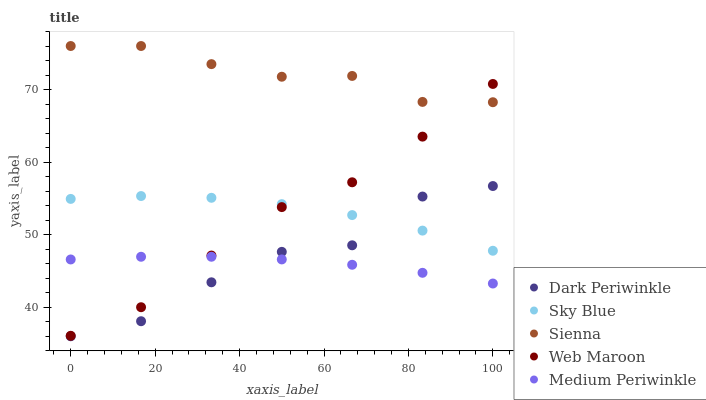Does Medium Periwinkle have the minimum area under the curve?
Answer yes or no. Yes. Does Sienna have the maximum area under the curve?
Answer yes or no. Yes. Does Sky Blue have the minimum area under the curve?
Answer yes or no. No. Does Sky Blue have the maximum area under the curve?
Answer yes or no. No. Is Medium Periwinkle the smoothest?
Answer yes or no. Yes. Is Dark Periwinkle the roughest?
Answer yes or no. Yes. Is Sky Blue the smoothest?
Answer yes or no. No. Is Sky Blue the roughest?
Answer yes or no. No. Does Dark Periwinkle have the lowest value?
Answer yes or no. Yes. Does Sky Blue have the lowest value?
Answer yes or no. No. Does Sienna have the highest value?
Answer yes or no. Yes. Does Sky Blue have the highest value?
Answer yes or no. No. Is Medium Periwinkle less than Sienna?
Answer yes or no. Yes. Is Sky Blue greater than Medium Periwinkle?
Answer yes or no. Yes. Does Medium Periwinkle intersect Web Maroon?
Answer yes or no. Yes. Is Medium Periwinkle less than Web Maroon?
Answer yes or no. No. Is Medium Periwinkle greater than Web Maroon?
Answer yes or no. No. Does Medium Periwinkle intersect Sienna?
Answer yes or no. No. 